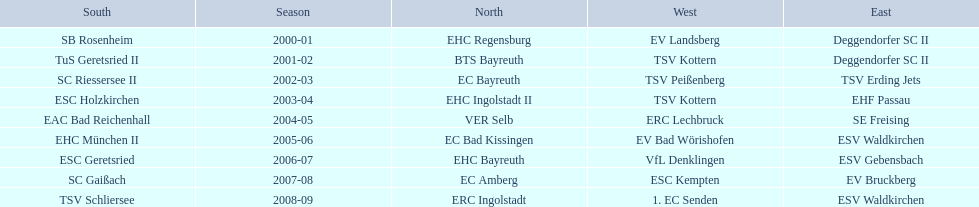Which teams played in the north? EHC Regensburg, BTS Bayreuth, EC Bayreuth, EHC Ingolstadt II, VER Selb, EC Bad Kissingen, EHC Bayreuth, EC Amberg, ERC Ingolstadt. Of these teams, which played during 2000-2001? EHC Regensburg. 